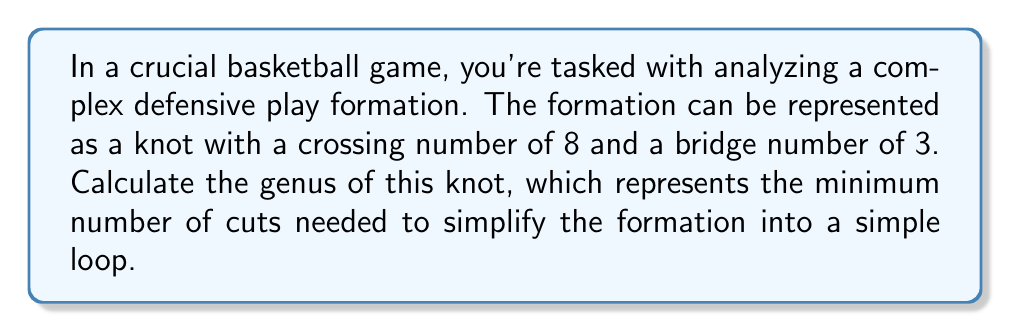Show me your answer to this math problem. To find the genus of the knot representing the defensive play formation, we'll use the following steps:

1. Recall the relationship between crossing number $c$, bridge number $b$, and genus $g$ for a knot:

   $$c \leq 2b(g+1) - 1$$

2. We're given:
   - Crossing number $c = 8$
   - Bridge number $b = 3$

3. Substitute these values into the inequality:

   $$8 \leq 2 \cdot 3(g+1) - 1$$

4. Simplify:
   $$8 \leq 6(g+1) - 1$$
   $$8 \leq 6g + 6 - 1$$
   $$8 \leq 6g + 5$$

5. Isolate $g$:
   $$3 \leq 6g$$
   $$\frac{1}{2} \leq g$$

6. Since genus must be a non-negative integer, the smallest possible value for $g$ that satisfies this inequality is 1.

Therefore, the genus of the knot representing the complex defensive play formation is 1.
Answer: 1 